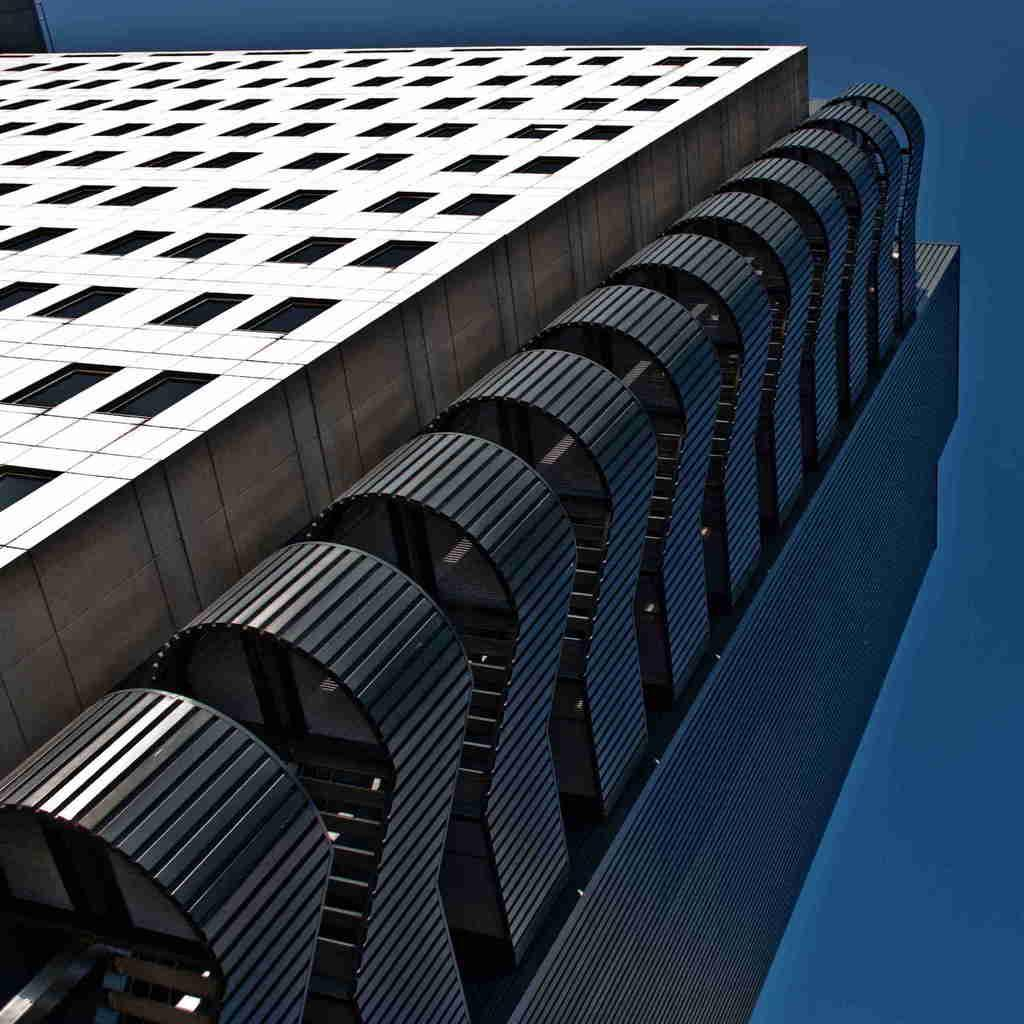What type of structure is in the image? There is a building in the image. Where is the building located in relation to the image? The building is in the foreground of the image. What can be seen in the background of the image? The sky is visible in the background of the image. What type of poison is being requested in the image? There is no mention of poison or any request in the image; it features a building in the foreground and the sky in the background. 